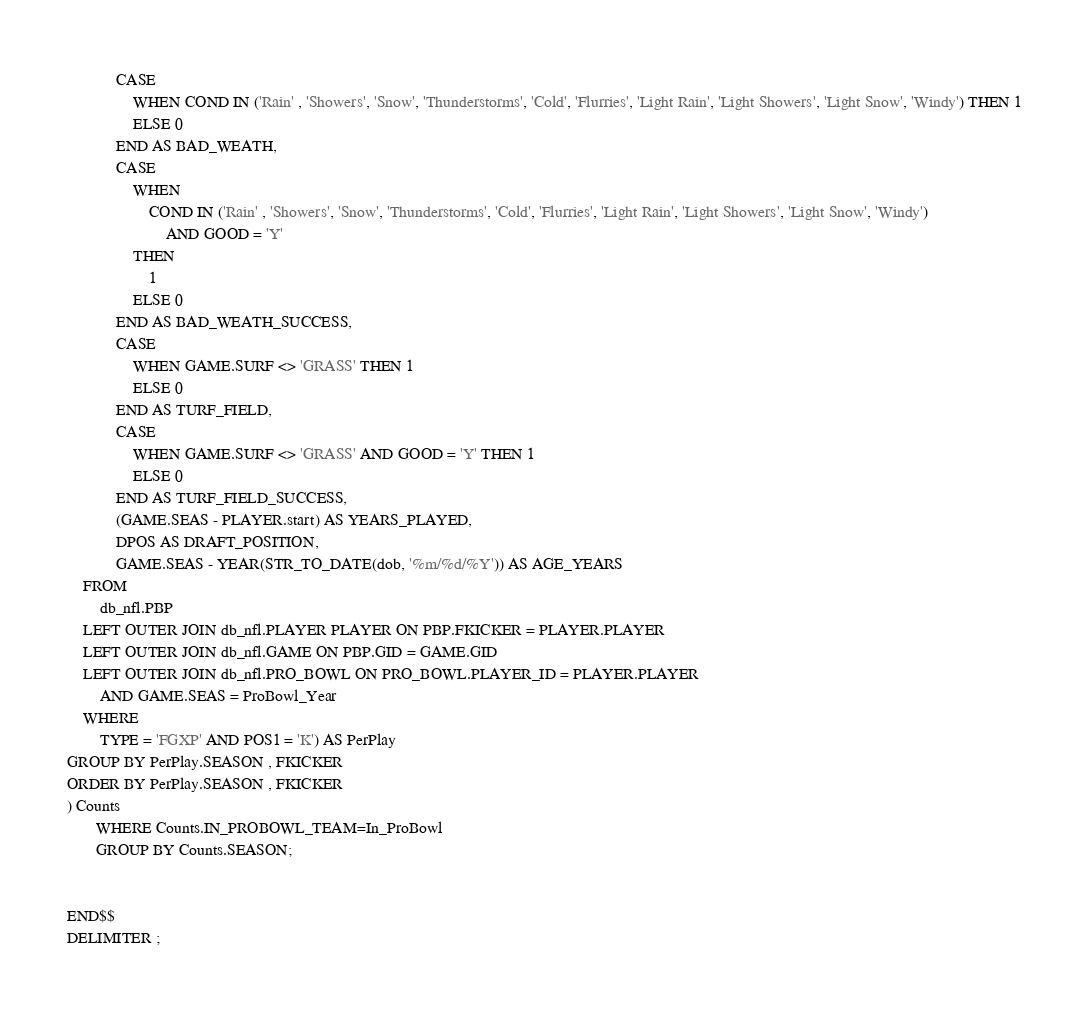<code> <loc_0><loc_0><loc_500><loc_500><_SQL_>            CASE
                WHEN COND IN ('Rain' , 'Showers', 'Snow', 'Thunderstorms', 'Cold', 'Flurries', 'Light Rain', 'Light Showers', 'Light Snow', 'Windy') THEN 1
                ELSE 0
            END AS BAD_WEATH,
            CASE
                WHEN
                    COND IN ('Rain' , 'Showers', 'Snow', 'Thunderstorms', 'Cold', 'Flurries', 'Light Rain', 'Light Showers', 'Light Snow', 'Windy')
                        AND GOOD = 'Y'
                THEN
                    1
                ELSE 0
            END AS BAD_WEATH_SUCCESS,
            CASE
                WHEN GAME.SURF <> 'GRASS' THEN 1
                ELSE 0
            END AS TURF_FIELD,
            CASE
                WHEN GAME.SURF <> 'GRASS' AND GOOD = 'Y' THEN 1
                ELSE 0
            END AS TURF_FIELD_SUCCESS,
            (GAME.SEAS - PLAYER.start) AS YEARS_PLAYED,
            DPOS AS DRAFT_POSITION,
            GAME.SEAS - YEAR(STR_TO_DATE(dob, '%m/%d/%Y')) AS AGE_YEARS
    FROM
        db_nfl.PBP
    LEFT OUTER JOIN db_nfl.PLAYER PLAYER ON PBP.FKICKER = PLAYER.PLAYER
    LEFT OUTER JOIN db_nfl.GAME ON PBP.GID = GAME.GID
    LEFT OUTER JOIN db_nfl.PRO_BOWL ON PRO_BOWL.PLAYER_ID = PLAYER.PLAYER
        AND GAME.SEAS = ProBowl_Year
    WHERE
        TYPE = 'FGXP' AND POS1 = 'K') AS PerPlay
GROUP BY PerPlay.SEASON , FKICKER
ORDER BY PerPlay.SEASON , FKICKER
) Counts
       WHERE Counts.IN_PROBOWL_TEAM=In_ProBowl
       GROUP BY Counts.SEASON;


END$$
DELIMITER ;
</code> 